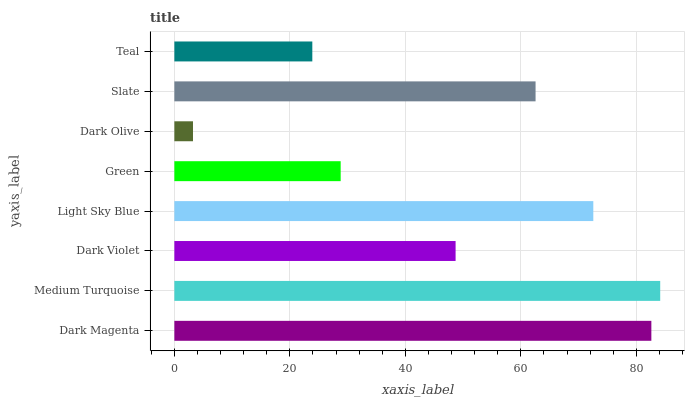Is Dark Olive the minimum?
Answer yes or no. Yes. Is Medium Turquoise the maximum?
Answer yes or no. Yes. Is Dark Violet the minimum?
Answer yes or no. No. Is Dark Violet the maximum?
Answer yes or no. No. Is Medium Turquoise greater than Dark Violet?
Answer yes or no. Yes. Is Dark Violet less than Medium Turquoise?
Answer yes or no. Yes. Is Dark Violet greater than Medium Turquoise?
Answer yes or no. No. Is Medium Turquoise less than Dark Violet?
Answer yes or no. No. Is Slate the high median?
Answer yes or no. Yes. Is Dark Violet the low median?
Answer yes or no. Yes. Is Teal the high median?
Answer yes or no. No. Is Slate the low median?
Answer yes or no. No. 